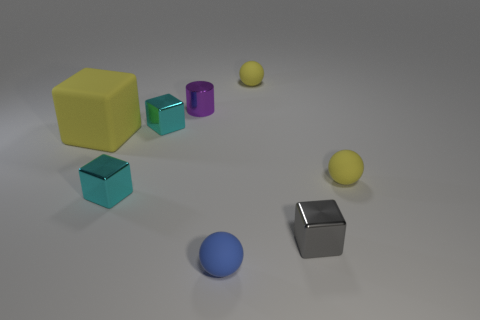Subtract all small yellow rubber balls. How many balls are left? 1 Subtract all yellow balls. How many balls are left? 1 Add 2 tiny blue matte spheres. How many objects exist? 10 Subtract all cylinders. How many objects are left? 7 Subtract all blue cylinders. How many yellow spheres are left? 2 Subtract all tiny gray blocks. Subtract all tiny cyan shiny objects. How many objects are left? 5 Add 7 yellow objects. How many yellow objects are left? 10 Add 8 tiny purple matte cylinders. How many tiny purple matte cylinders exist? 8 Subtract 0 blue blocks. How many objects are left? 8 Subtract 1 spheres. How many spheres are left? 2 